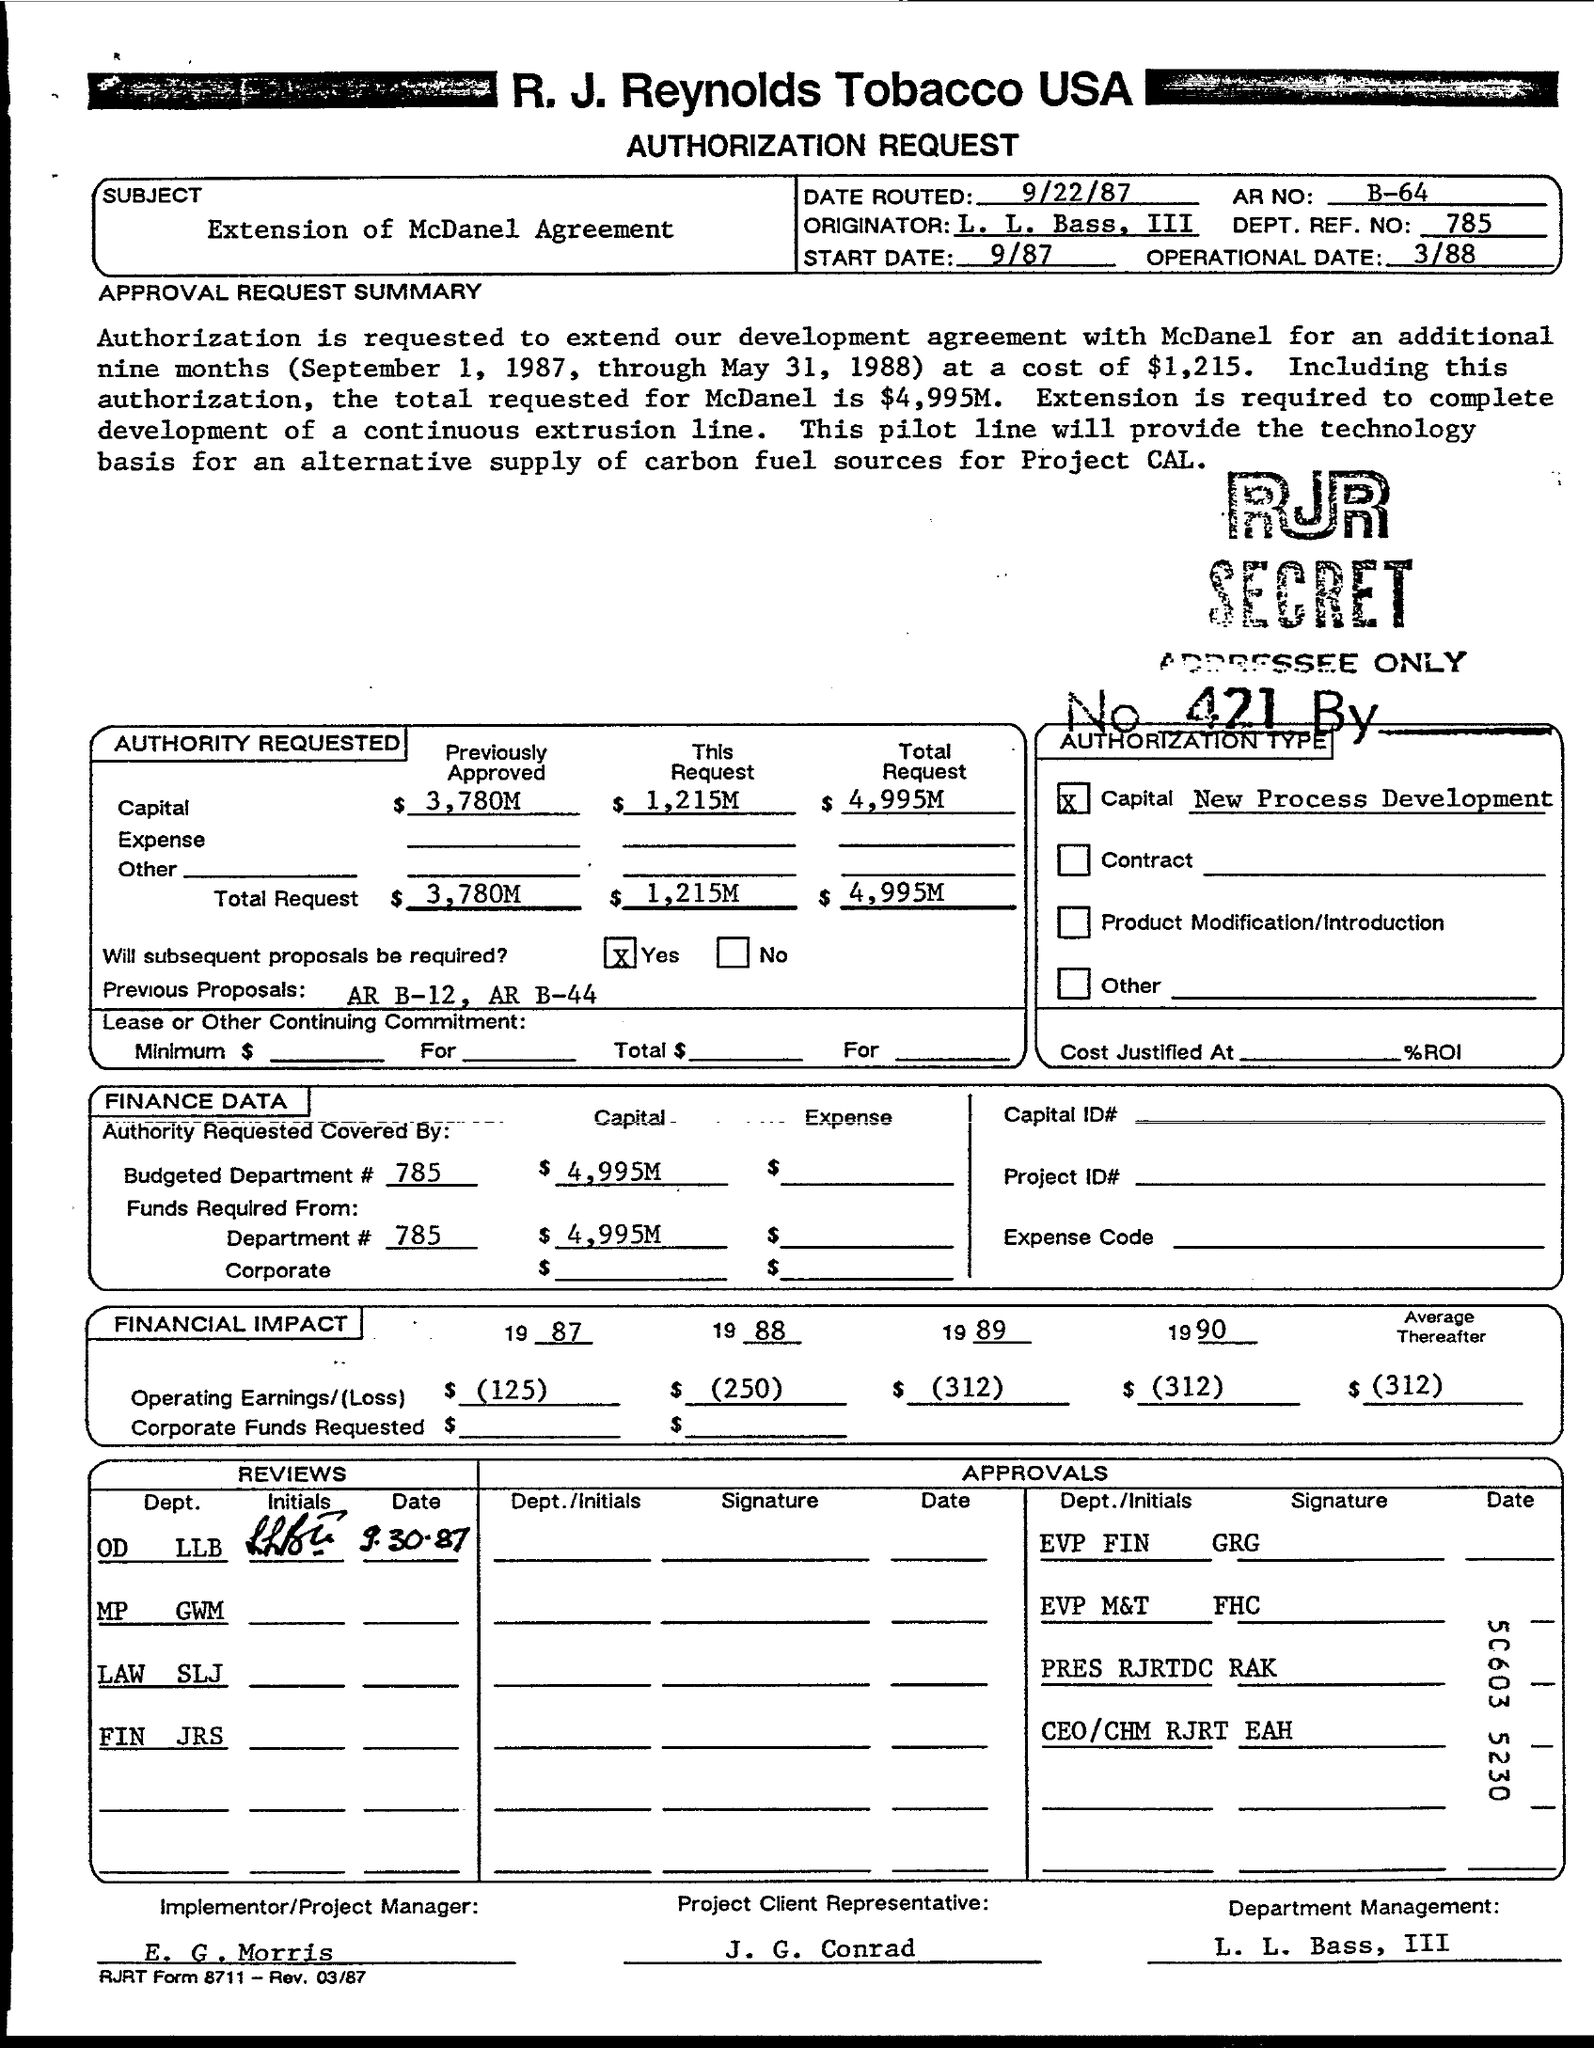Give some essential details in this illustration. The total request capital as stated in the document is $4,995 million. This is the authorization request from R. J. Reynolds Tobacco USA. The subject mentioned in the document is the extension of the McDanel Agreement. The document contains the DEPT. REF NO. 785. The Project Client Representative, as stated in the document, is J. G. Conrad. 